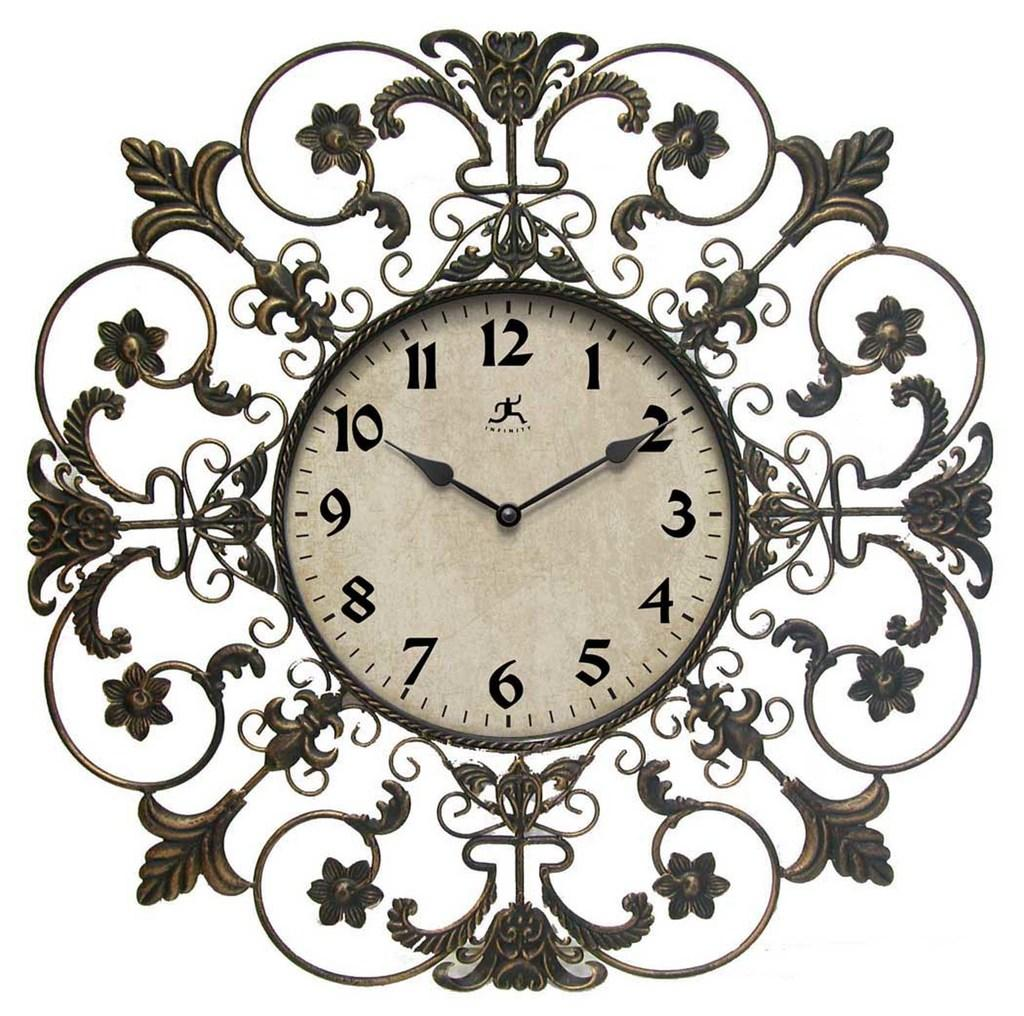<image>
Offer a succinct explanation of the picture presented. Old clock that has the hands pointing at 10 and 2. 